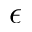<formula> <loc_0><loc_0><loc_500><loc_500>\epsilon</formula> 